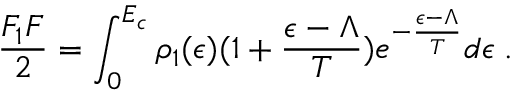<formula> <loc_0><loc_0><loc_500><loc_500>{ \frac { F _ { 1 } F } { 2 } } = \int _ { 0 } ^ { E _ { c } } \rho _ { 1 } ( \epsilon ) ( 1 + { \frac { \epsilon - \Lambda } { T } } ) e ^ { - { \frac { \epsilon - \Lambda } { T } } } d \epsilon \, .</formula> 